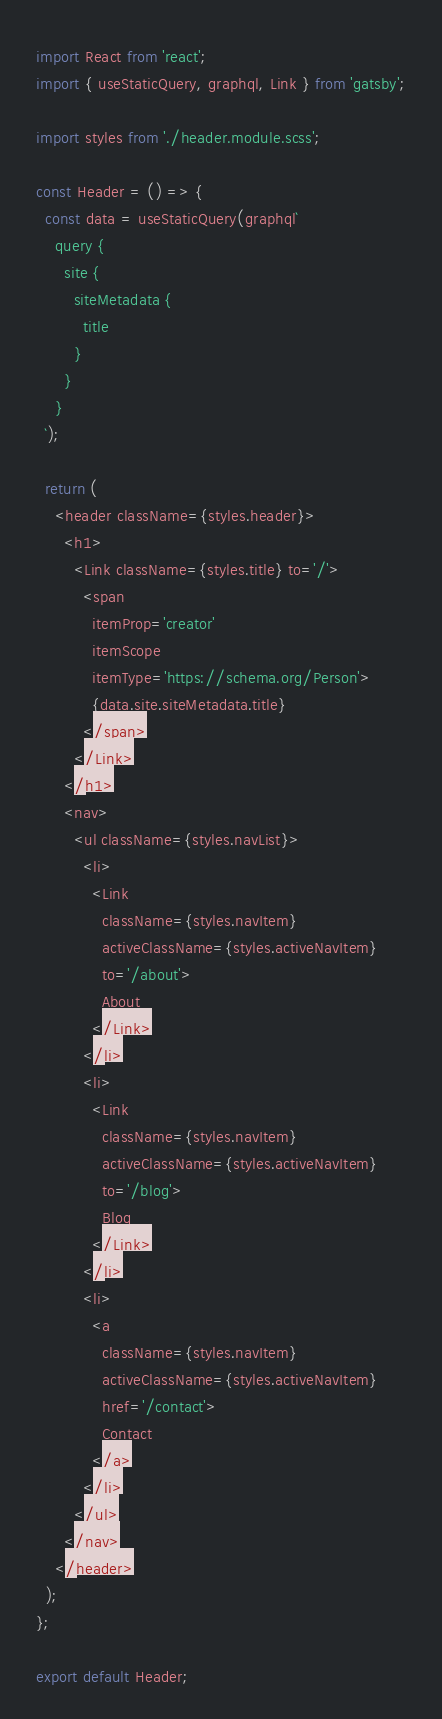Convert code to text. <code><loc_0><loc_0><loc_500><loc_500><_JavaScript_>import React from 'react';
import { useStaticQuery, graphql, Link } from 'gatsby';

import styles from './header.module.scss';

const Header = () => {
  const data = useStaticQuery(graphql`
    query {
      site {
        siteMetadata {
          title
        }
      }
    }
  `);

  return (
    <header className={styles.header}>
      <h1>
        <Link className={styles.title} to='/'>
          <span
            itemProp='creator'
            itemScope
            itemType='https://schema.org/Person'>
            {data.site.siteMetadata.title}
          </span>
        </Link>
      </h1>
      <nav>
        <ul className={styles.navList}>
          <li>
            <Link
              className={styles.navItem}
              activeClassName={styles.activeNavItem}
              to='/about'>
              About
            </Link>
          </li>
          <li>
            <Link
              className={styles.navItem}
              activeClassName={styles.activeNavItem}
              to='/blog'>
              Blog
            </Link>
          </li>
          <li>
            <a
              className={styles.navItem}
              activeClassName={styles.activeNavItem}
              href='/contact'>
              Contact
            </a>
          </li>
        </ul>
      </nav>
    </header>
  );
};

export default Header;
</code> 